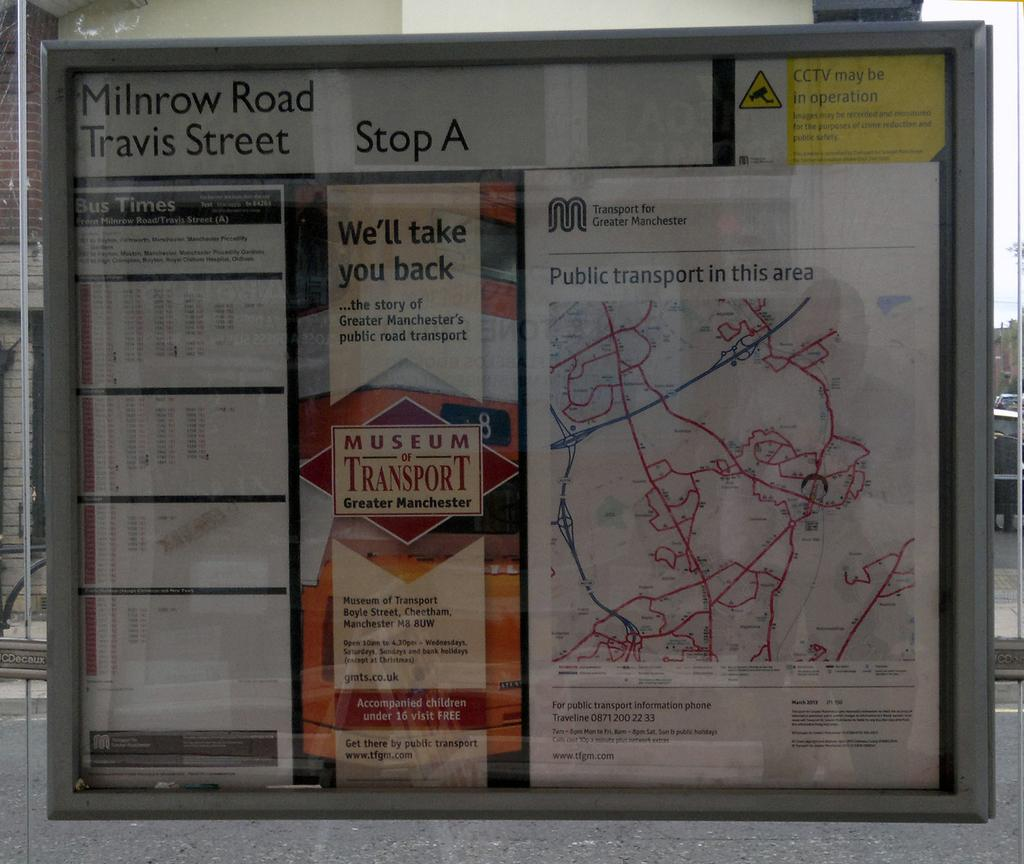<image>
Offer a succinct explanation of the picture presented. A display with several posters including one for near by bus routes. 